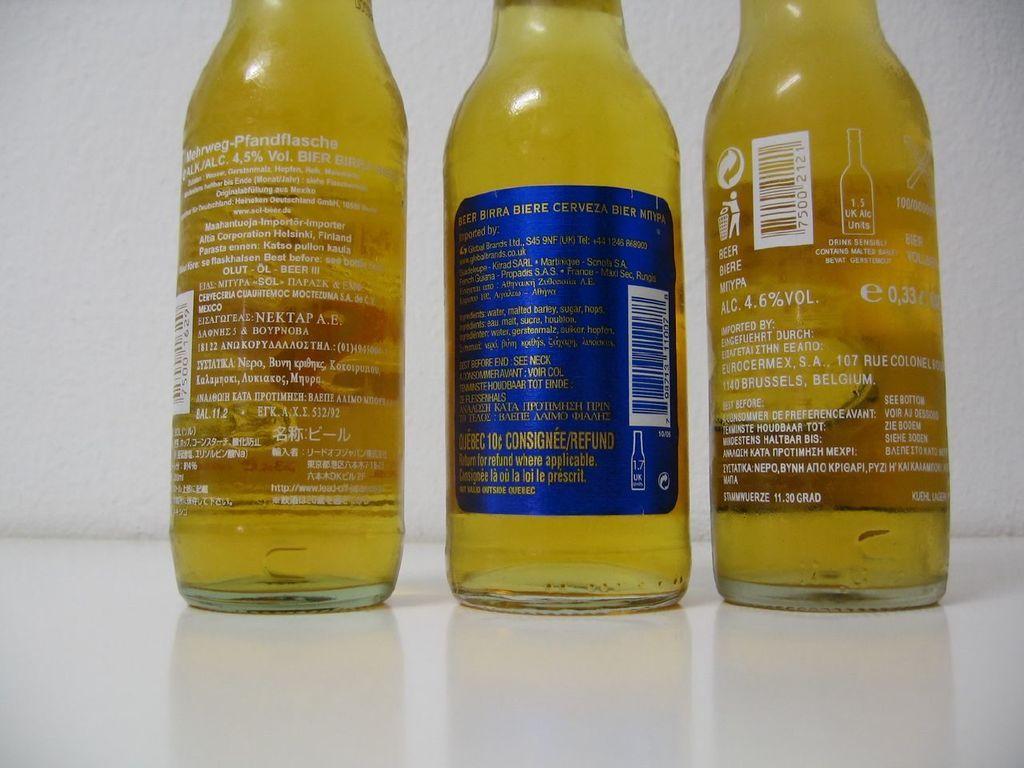Could you give a brief overview of what you see in this image? In this picture there are three bottles which are yellow in color. 